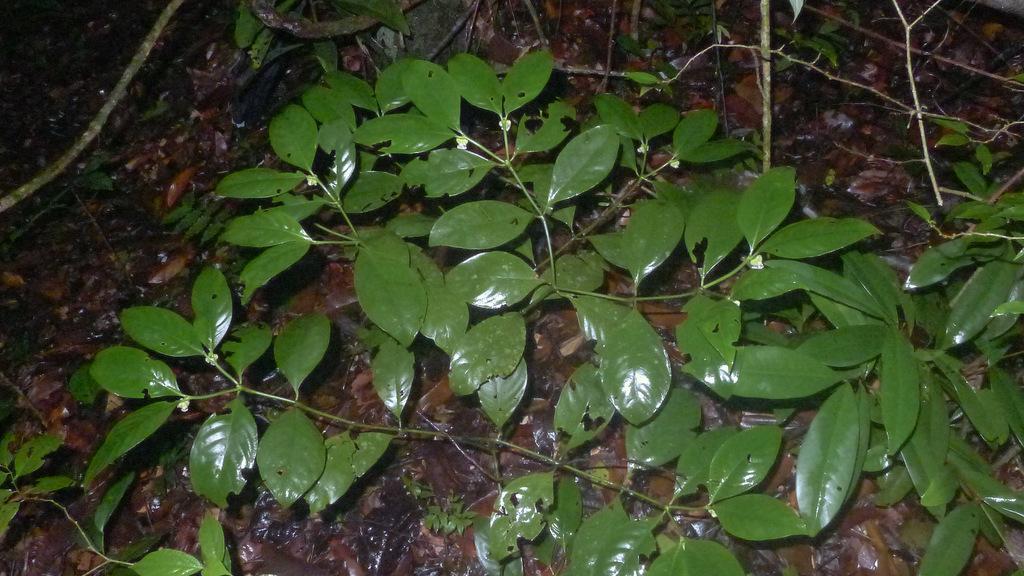Can you describe this image briefly? In the center of the image we can see plants, dry leaves, sticks etc. 